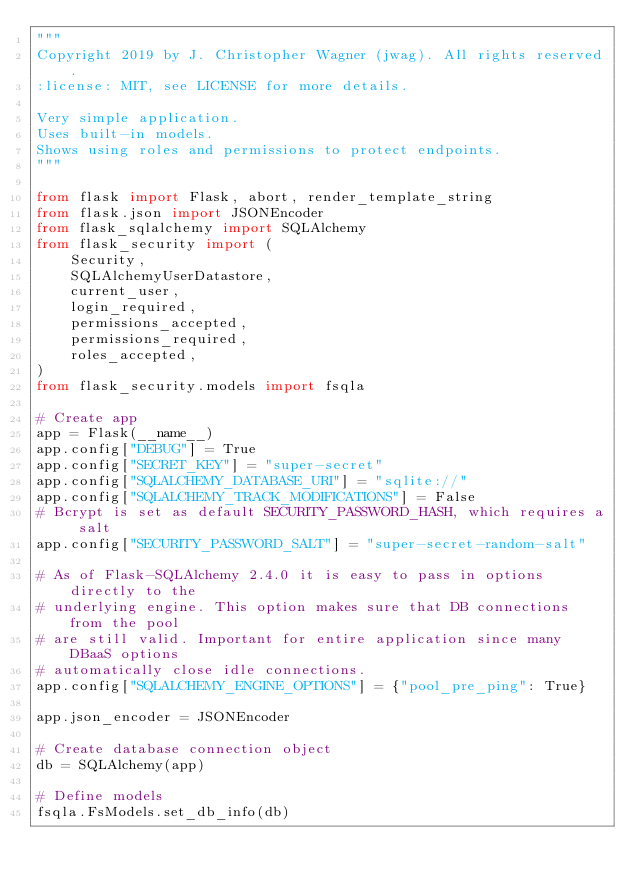Convert code to text. <code><loc_0><loc_0><loc_500><loc_500><_Python_>"""
Copyright 2019 by J. Christopher Wagner (jwag). All rights reserved.
:license: MIT, see LICENSE for more details.

Very simple application.
Uses built-in models.
Shows using roles and permissions to protect endpoints.
"""

from flask import Flask, abort, render_template_string
from flask.json import JSONEncoder
from flask_sqlalchemy import SQLAlchemy
from flask_security import (
    Security,
    SQLAlchemyUserDatastore,
    current_user,
    login_required,
    permissions_accepted,
    permissions_required,
    roles_accepted,
)
from flask_security.models import fsqla

# Create app
app = Flask(__name__)
app.config["DEBUG"] = True
app.config["SECRET_KEY"] = "super-secret"
app.config["SQLALCHEMY_DATABASE_URI"] = "sqlite://"
app.config["SQLALCHEMY_TRACK_MODIFICATIONS"] = False
# Bcrypt is set as default SECURITY_PASSWORD_HASH, which requires a salt
app.config["SECURITY_PASSWORD_SALT"] = "super-secret-random-salt"

# As of Flask-SQLAlchemy 2.4.0 it is easy to pass in options directly to the
# underlying engine. This option makes sure that DB connections from the pool
# are still valid. Important for entire application since many DBaaS options
# automatically close idle connections.
app.config["SQLALCHEMY_ENGINE_OPTIONS"] = {"pool_pre_ping": True}

app.json_encoder = JSONEncoder

# Create database connection object
db = SQLAlchemy(app)

# Define models
fsqla.FsModels.set_db_info(db)

</code> 